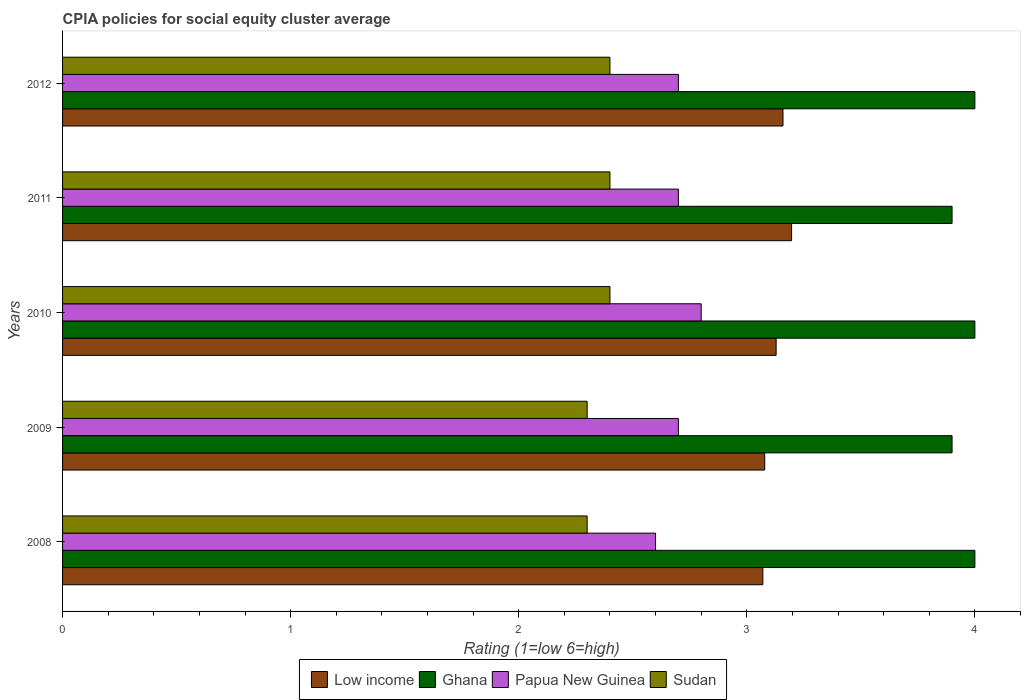Are the number of bars per tick equal to the number of legend labels?
Your answer should be compact. Yes. How many bars are there on the 2nd tick from the bottom?
Your answer should be compact. 4. What is the label of the 2nd group of bars from the top?
Your answer should be compact. 2011. What is the CPIA rating in Ghana in 2008?
Your answer should be compact. 4. Across all years, what is the maximum CPIA rating in Ghana?
Your answer should be very brief. 4. Across all years, what is the minimum CPIA rating in Ghana?
Give a very brief answer. 3.9. In which year was the CPIA rating in Sudan minimum?
Ensure brevity in your answer.  2008. What is the total CPIA rating in Low income in the graph?
Your answer should be very brief. 15.63. What is the difference between the CPIA rating in Ghana in 2011 and that in 2012?
Your answer should be very brief. -0.1. What is the difference between the CPIA rating in Low income in 2010 and the CPIA rating in Papua New Guinea in 2011?
Provide a succinct answer. 0.43. What is the average CPIA rating in Low income per year?
Provide a succinct answer. 3.13. In the year 2008, what is the difference between the CPIA rating in Low income and CPIA rating in Sudan?
Make the answer very short. 0.77. In how many years, is the CPIA rating in Papua New Guinea greater than 4 ?
Provide a succinct answer. 0. What is the ratio of the CPIA rating in Papua New Guinea in 2008 to that in 2010?
Give a very brief answer. 0.93. Is the CPIA rating in Sudan in 2008 less than that in 2012?
Ensure brevity in your answer.  Yes. What is the difference between the highest and the second highest CPIA rating in Low income?
Provide a succinct answer. 0.04. What is the difference between the highest and the lowest CPIA rating in Papua New Guinea?
Your response must be concise. 0.2. In how many years, is the CPIA rating in Sudan greater than the average CPIA rating in Sudan taken over all years?
Give a very brief answer. 3. Is it the case that in every year, the sum of the CPIA rating in Sudan and CPIA rating in Papua New Guinea is greater than the sum of CPIA rating in Low income and CPIA rating in Ghana?
Keep it short and to the point. Yes. What does the 1st bar from the top in 2010 represents?
Ensure brevity in your answer.  Sudan. What does the 1st bar from the bottom in 2011 represents?
Your response must be concise. Low income. Does the graph contain any zero values?
Your answer should be very brief. No. Where does the legend appear in the graph?
Provide a short and direct response. Bottom center. How many legend labels are there?
Give a very brief answer. 4. How are the legend labels stacked?
Your response must be concise. Horizontal. What is the title of the graph?
Your answer should be very brief. CPIA policies for social equity cluster average. What is the label or title of the X-axis?
Your answer should be very brief. Rating (1=low 6=high). What is the label or title of the Y-axis?
Offer a very short reply. Years. What is the Rating (1=low 6=high) of Low income in 2008?
Keep it short and to the point. 3.07. What is the Rating (1=low 6=high) of Low income in 2009?
Your answer should be compact. 3.08. What is the Rating (1=low 6=high) of Ghana in 2009?
Provide a succinct answer. 3.9. What is the Rating (1=low 6=high) in Papua New Guinea in 2009?
Ensure brevity in your answer.  2.7. What is the Rating (1=low 6=high) of Low income in 2010?
Provide a succinct answer. 3.13. What is the Rating (1=low 6=high) in Papua New Guinea in 2010?
Your answer should be compact. 2.8. What is the Rating (1=low 6=high) of Low income in 2011?
Ensure brevity in your answer.  3.2. What is the Rating (1=low 6=high) in Low income in 2012?
Offer a very short reply. 3.16. What is the Rating (1=low 6=high) in Ghana in 2012?
Provide a succinct answer. 4. What is the Rating (1=low 6=high) in Papua New Guinea in 2012?
Make the answer very short. 2.7. Across all years, what is the maximum Rating (1=low 6=high) of Low income?
Provide a short and direct response. 3.2. Across all years, what is the maximum Rating (1=low 6=high) in Sudan?
Offer a very short reply. 2.4. Across all years, what is the minimum Rating (1=low 6=high) of Low income?
Provide a short and direct response. 3.07. Across all years, what is the minimum Rating (1=low 6=high) of Sudan?
Provide a succinct answer. 2.3. What is the total Rating (1=low 6=high) of Low income in the graph?
Ensure brevity in your answer.  15.63. What is the total Rating (1=low 6=high) of Ghana in the graph?
Provide a short and direct response. 19.8. What is the difference between the Rating (1=low 6=high) of Low income in 2008 and that in 2009?
Your answer should be very brief. -0.01. What is the difference between the Rating (1=low 6=high) of Ghana in 2008 and that in 2009?
Give a very brief answer. 0.1. What is the difference between the Rating (1=low 6=high) of Low income in 2008 and that in 2010?
Your response must be concise. -0.06. What is the difference between the Rating (1=low 6=high) in Ghana in 2008 and that in 2010?
Give a very brief answer. 0. What is the difference between the Rating (1=low 6=high) of Low income in 2008 and that in 2011?
Ensure brevity in your answer.  -0.13. What is the difference between the Rating (1=low 6=high) of Ghana in 2008 and that in 2011?
Keep it short and to the point. 0.1. What is the difference between the Rating (1=low 6=high) of Sudan in 2008 and that in 2011?
Your response must be concise. -0.1. What is the difference between the Rating (1=low 6=high) of Low income in 2008 and that in 2012?
Your response must be concise. -0.09. What is the difference between the Rating (1=low 6=high) of Low income in 2009 and that in 2010?
Keep it short and to the point. -0.05. What is the difference between the Rating (1=low 6=high) of Ghana in 2009 and that in 2010?
Provide a short and direct response. -0.1. What is the difference between the Rating (1=low 6=high) of Papua New Guinea in 2009 and that in 2010?
Your answer should be very brief. -0.1. What is the difference between the Rating (1=low 6=high) of Sudan in 2009 and that in 2010?
Make the answer very short. -0.1. What is the difference between the Rating (1=low 6=high) of Low income in 2009 and that in 2011?
Your answer should be compact. -0.12. What is the difference between the Rating (1=low 6=high) in Ghana in 2009 and that in 2011?
Offer a very short reply. 0. What is the difference between the Rating (1=low 6=high) of Sudan in 2009 and that in 2011?
Your answer should be very brief. -0.1. What is the difference between the Rating (1=low 6=high) of Low income in 2009 and that in 2012?
Your answer should be compact. -0.08. What is the difference between the Rating (1=low 6=high) in Papua New Guinea in 2009 and that in 2012?
Give a very brief answer. 0. What is the difference between the Rating (1=low 6=high) of Sudan in 2009 and that in 2012?
Provide a succinct answer. -0.1. What is the difference between the Rating (1=low 6=high) in Low income in 2010 and that in 2011?
Offer a very short reply. -0.07. What is the difference between the Rating (1=low 6=high) of Low income in 2010 and that in 2012?
Offer a very short reply. -0.03. What is the difference between the Rating (1=low 6=high) of Low income in 2011 and that in 2012?
Keep it short and to the point. 0.04. What is the difference between the Rating (1=low 6=high) of Ghana in 2011 and that in 2012?
Give a very brief answer. -0.1. What is the difference between the Rating (1=low 6=high) of Papua New Guinea in 2011 and that in 2012?
Offer a terse response. 0. What is the difference between the Rating (1=low 6=high) of Low income in 2008 and the Rating (1=low 6=high) of Ghana in 2009?
Your response must be concise. -0.83. What is the difference between the Rating (1=low 6=high) in Low income in 2008 and the Rating (1=low 6=high) in Papua New Guinea in 2009?
Your answer should be very brief. 0.37. What is the difference between the Rating (1=low 6=high) of Low income in 2008 and the Rating (1=low 6=high) of Sudan in 2009?
Your answer should be compact. 0.77. What is the difference between the Rating (1=low 6=high) of Ghana in 2008 and the Rating (1=low 6=high) of Sudan in 2009?
Provide a succinct answer. 1.7. What is the difference between the Rating (1=low 6=high) in Papua New Guinea in 2008 and the Rating (1=low 6=high) in Sudan in 2009?
Make the answer very short. 0.3. What is the difference between the Rating (1=low 6=high) of Low income in 2008 and the Rating (1=low 6=high) of Ghana in 2010?
Offer a very short reply. -0.93. What is the difference between the Rating (1=low 6=high) of Low income in 2008 and the Rating (1=low 6=high) of Papua New Guinea in 2010?
Give a very brief answer. 0.27. What is the difference between the Rating (1=low 6=high) of Low income in 2008 and the Rating (1=low 6=high) of Sudan in 2010?
Make the answer very short. 0.67. What is the difference between the Rating (1=low 6=high) of Papua New Guinea in 2008 and the Rating (1=low 6=high) of Sudan in 2010?
Offer a terse response. 0.2. What is the difference between the Rating (1=low 6=high) in Low income in 2008 and the Rating (1=low 6=high) in Ghana in 2011?
Make the answer very short. -0.83. What is the difference between the Rating (1=low 6=high) of Low income in 2008 and the Rating (1=low 6=high) of Papua New Guinea in 2011?
Provide a succinct answer. 0.37. What is the difference between the Rating (1=low 6=high) in Low income in 2008 and the Rating (1=low 6=high) in Sudan in 2011?
Offer a terse response. 0.67. What is the difference between the Rating (1=low 6=high) of Low income in 2008 and the Rating (1=low 6=high) of Ghana in 2012?
Offer a terse response. -0.93. What is the difference between the Rating (1=low 6=high) in Low income in 2008 and the Rating (1=low 6=high) in Papua New Guinea in 2012?
Make the answer very short. 0.37. What is the difference between the Rating (1=low 6=high) in Low income in 2008 and the Rating (1=low 6=high) in Sudan in 2012?
Your response must be concise. 0.67. What is the difference between the Rating (1=low 6=high) of Ghana in 2008 and the Rating (1=low 6=high) of Papua New Guinea in 2012?
Make the answer very short. 1.3. What is the difference between the Rating (1=low 6=high) in Low income in 2009 and the Rating (1=low 6=high) in Ghana in 2010?
Offer a terse response. -0.92. What is the difference between the Rating (1=low 6=high) in Low income in 2009 and the Rating (1=low 6=high) in Papua New Guinea in 2010?
Provide a succinct answer. 0.28. What is the difference between the Rating (1=low 6=high) of Low income in 2009 and the Rating (1=low 6=high) of Sudan in 2010?
Provide a succinct answer. 0.68. What is the difference between the Rating (1=low 6=high) of Low income in 2009 and the Rating (1=low 6=high) of Ghana in 2011?
Ensure brevity in your answer.  -0.82. What is the difference between the Rating (1=low 6=high) of Low income in 2009 and the Rating (1=low 6=high) of Papua New Guinea in 2011?
Keep it short and to the point. 0.38. What is the difference between the Rating (1=low 6=high) in Low income in 2009 and the Rating (1=low 6=high) in Sudan in 2011?
Your answer should be compact. 0.68. What is the difference between the Rating (1=low 6=high) in Ghana in 2009 and the Rating (1=low 6=high) in Sudan in 2011?
Your answer should be very brief. 1.5. What is the difference between the Rating (1=low 6=high) in Low income in 2009 and the Rating (1=low 6=high) in Ghana in 2012?
Give a very brief answer. -0.92. What is the difference between the Rating (1=low 6=high) of Low income in 2009 and the Rating (1=low 6=high) of Papua New Guinea in 2012?
Your answer should be very brief. 0.38. What is the difference between the Rating (1=low 6=high) of Low income in 2009 and the Rating (1=low 6=high) of Sudan in 2012?
Offer a very short reply. 0.68. What is the difference between the Rating (1=low 6=high) of Ghana in 2009 and the Rating (1=low 6=high) of Papua New Guinea in 2012?
Keep it short and to the point. 1.2. What is the difference between the Rating (1=low 6=high) of Papua New Guinea in 2009 and the Rating (1=low 6=high) of Sudan in 2012?
Offer a very short reply. 0.3. What is the difference between the Rating (1=low 6=high) in Low income in 2010 and the Rating (1=low 6=high) in Ghana in 2011?
Give a very brief answer. -0.77. What is the difference between the Rating (1=low 6=high) in Low income in 2010 and the Rating (1=low 6=high) in Papua New Guinea in 2011?
Your answer should be very brief. 0.43. What is the difference between the Rating (1=low 6=high) in Low income in 2010 and the Rating (1=low 6=high) in Sudan in 2011?
Ensure brevity in your answer.  0.73. What is the difference between the Rating (1=low 6=high) of Ghana in 2010 and the Rating (1=low 6=high) of Papua New Guinea in 2011?
Ensure brevity in your answer.  1.3. What is the difference between the Rating (1=low 6=high) of Ghana in 2010 and the Rating (1=low 6=high) of Sudan in 2011?
Keep it short and to the point. 1.6. What is the difference between the Rating (1=low 6=high) of Papua New Guinea in 2010 and the Rating (1=low 6=high) of Sudan in 2011?
Offer a terse response. 0.4. What is the difference between the Rating (1=low 6=high) of Low income in 2010 and the Rating (1=low 6=high) of Ghana in 2012?
Your answer should be very brief. -0.87. What is the difference between the Rating (1=low 6=high) of Low income in 2010 and the Rating (1=low 6=high) of Papua New Guinea in 2012?
Your response must be concise. 0.43. What is the difference between the Rating (1=low 6=high) in Low income in 2010 and the Rating (1=low 6=high) in Sudan in 2012?
Ensure brevity in your answer.  0.73. What is the difference between the Rating (1=low 6=high) of Ghana in 2010 and the Rating (1=low 6=high) of Papua New Guinea in 2012?
Your response must be concise. 1.3. What is the difference between the Rating (1=low 6=high) in Low income in 2011 and the Rating (1=low 6=high) in Ghana in 2012?
Offer a very short reply. -0.8. What is the difference between the Rating (1=low 6=high) of Low income in 2011 and the Rating (1=low 6=high) of Papua New Guinea in 2012?
Provide a short and direct response. 0.5. What is the difference between the Rating (1=low 6=high) in Low income in 2011 and the Rating (1=low 6=high) in Sudan in 2012?
Provide a short and direct response. 0.8. What is the difference between the Rating (1=low 6=high) of Ghana in 2011 and the Rating (1=low 6=high) of Sudan in 2012?
Your answer should be very brief. 1.5. What is the difference between the Rating (1=low 6=high) in Papua New Guinea in 2011 and the Rating (1=low 6=high) in Sudan in 2012?
Your answer should be compact. 0.3. What is the average Rating (1=low 6=high) of Low income per year?
Your answer should be very brief. 3.13. What is the average Rating (1=low 6=high) of Ghana per year?
Offer a very short reply. 3.96. What is the average Rating (1=low 6=high) in Sudan per year?
Your answer should be compact. 2.36. In the year 2008, what is the difference between the Rating (1=low 6=high) of Low income and Rating (1=low 6=high) of Ghana?
Give a very brief answer. -0.93. In the year 2008, what is the difference between the Rating (1=low 6=high) in Low income and Rating (1=low 6=high) in Papua New Guinea?
Provide a succinct answer. 0.47. In the year 2008, what is the difference between the Rating (1=low 6=high) of Low income and Rating (1=low 6=high) of Sudan?
Offer a very short reply. 0.77. In the year 2008, what is the difference between the Rating (1=low 6=high) of Papua New Guinea and Rating (1=low 6=high) of Sudan?
Your answer should be compact. 0.3. In the year 2009, what is the difference between the Rating (1=low 6=high) in Low income and Rating (1=low 6=high) in Ghana?
Offer a terse response. -0.82. In the year 2009, what is the difference between the Rating (1=low 6=high) in Low income and Rating (1=low 6=high) in Papua New Guinea?
Your answer should be very brief. 0.38. In the year 2009, what is the difference between the Rating (1=low 6=high) in Low income and Rating (1=low 6=high) in Sudan?
Keep it short and to the point. 0.78. In the year 2009, what is the difference between the Rating (1=low 6=high) of Papua New Guinea and Rating (1=low 6=high) of Sudan?
Offer a terse response. 0.4. In the year 2010, what is the difference between the Rating (1=low 6=high) of Low income and Rating (1=low 6=high) of Ghana?
Your answer should be very brief. -0.87. In the year 2010, what is the difference between the Rating (1=low 6=high) of Low income and Rating (1=low 6=high) of Papua New Guinea?
Ensure brevity in your answer.  0.33. In the year 2010, what is the difference between the Rating (1=low 6=high) in Low income and Rating (1=low 6=high) in Sudan?
Make the answer very short. 0.73. In the year 2010, what is the difference between the Rating (1=low 6=high) in Ghana and Rating (1=low 6=high) in Papua New Guinea?
Ensure brevity in your answer.  1.2. In the year 2011, what is the difference between the Rating (1=low 6=high) of Low income and Rating (1=low 6=high) of Ghana?
Provide a succinct answer. -0.7. In the year 2011, what is the difference between the Rating (1=low 6=high) of Low income and Rating (1=low 6=high) of Papua New Guinea?
Ensure brevity in your answer.  0.5. In the year 2011, what is the difference between the Rating (1=low 6=high) of Low income and Rating (1=low 6=high) of Sudan?
Offer a terse response. 0.8. In the year 2011, what is the difference between the Rating (1=low 6=high) of Ghana and Rating (1=low 6=high) of Sudan?
Give a very brief answer. 1.5. In the year 2011, what is the difference between the Rating (1=low 6=high) in Papua New Guinea and Rating (1=low 6=high) in Sudan?
Make the answer very short. 0.3. In the year 2012, what is the difference between the Rating (1=low 6=high) of Low income and Rating (1=low 6=high) of Ghana?
Offer a terse response. -0.84. In the year 2012, what is the difference between the Rating (1=low 6=high) in Low income and Rating (1=low 6=high) in Papua New Guinea?
Keep it short and to the point. 0.46. In the year 2012, what is the difference between the Rating (1=low 6=high) in Low income and Rating (1=low 6=high) in Sudan?
Your answer should be compact. 0.76. In the year 2012, what is the difference between the Rating (1=low 6=high) of Ghana and Rating (1=low 6=high) of Papua New Guinea?
Keep it short and to the point. 1.3. What is the ratio of the Rating (1=low 6=high) of Ghana in 2008 to that in 2009?
Your answer should be compact. 1.03. What is the ratio of the Rating (1=low 6=high) in Sudan in 2008 to that in 2009?
Make the answer very short. 1. What is the ratio of the Rating (1=low 6=high) in Low income in 2008 to that in 2010?
Offer a very short reply. 0.98. What is the ratio of the Rating (1=low 6=high) in Low income in 2008 to that in 2011?
Your response must be concise. 0.96. What is the ratio of the Rating (1=low 6=high) in Ghana in 2008 to that in 2011?
Make the answer very short. 1.03. What is the ratio of the Rating (1=low 6=high) of Sudan in 2008 to that in 2011?
Offer a very short reply. 0.96. What is the ratio of the Rating (1=low 6=high) of Low income in 2008 to that in 2012?
Offer a very short reply. 0.97. What is the ratio of the Rating (1=low 6=high) of Ghana in 2008 to that in 2012?
Your answer should be compact. 1. What is the ratio of the Rating (1=low 6=high) of Sudan in 2008 to that in 2012?
Give a very brief answer. 0.96. What is the ratio of the Rating (1=low 6=high) of Sudan in 2009 to that in 2010?
Offer a very short reply. 0.96. What is the ratio of the Rating (1=low 6=high) in Low income in 2009 to that in 2011?
Your answer should be very brief. 0.96. What is the ratio of the Rating (1=low 6=high) of Ghana in 2009 to that in 2011?
Your answer should be compact. 1. What is the ratio of the Rating (1=low 6=high) in Papua New Guinea in 2009 to that in 2011?
Ensure brevity in your answer.  1. What is the ratio of the Rating (1=low 6=high) of Sudan in 2009 to that in 2011?
Your answer should be very brief. 0.96. What is the ratio of the Rating (1=low 6=high) in Low income in 2009 to that in 2012?
Give a very brief answer. 0.97. What is the ratio of the Rating (1=low 6=high) of Ghana in 2009 to that in 2012?
Ensure brevity in your answer.  0.97. What is the ratio of the Rating (1=low 6=high) of Papua New Guinea in 2009 to that in 2012?
Provide a succinct answer. 1. What is the ratio of the Rating (1=low 6=high) of Low income in 2010 to that in 2011?
Offer a very short reply. 0.98. What is the ratio of the Rating (1=low 6=high) in Ghana in 2010 to that in 2011?
Offer a terse response. 1.03. What is the ratio of the Rating (1=low 6=high) of Papua New Guinea in 2010 to that in 2011?
Your response must be concise. 1.04. What is the ratio of the Rating (1=low 6=high) in Low income in 2010 to that in 2012?
Provide a short and direct response. 0.99. What is the ratio of the Rating (1=low 6=high) in Ghana in 2010 to that in 2012?
Give a very brief answer. 1. What is the ratio of the Rating (1=low 6=high) of Low income in 2011 to that in 2012?
Give a very brief answer. 1.01. What is the ratio of the Rating (1=low 6=high) in Sudan in 2011 to that in 2012?
Provide a succinct answer. 1. What is the difference between the highest and the second highest Rating (1=low 6=high) in Low income?
Make the answer very short. 0.04. What is the difference between the highest and the second highest Rating (1=low 6=high) in Ghana?
Provide a succinct answer. 0. What is the difference between the highest and the second highest Rating (1=low 6=high) of Sudan?
Your answer should be compact. 0. What is the difference between the highest and the lowest Rating (1=low 6=high) in Low income?
Offer a very short reply. 0.13. What is the difference between the highest and the lowest Rating (1=low 6=high) of Papua New Guinea?
Offer a very short reply. 0.2. 